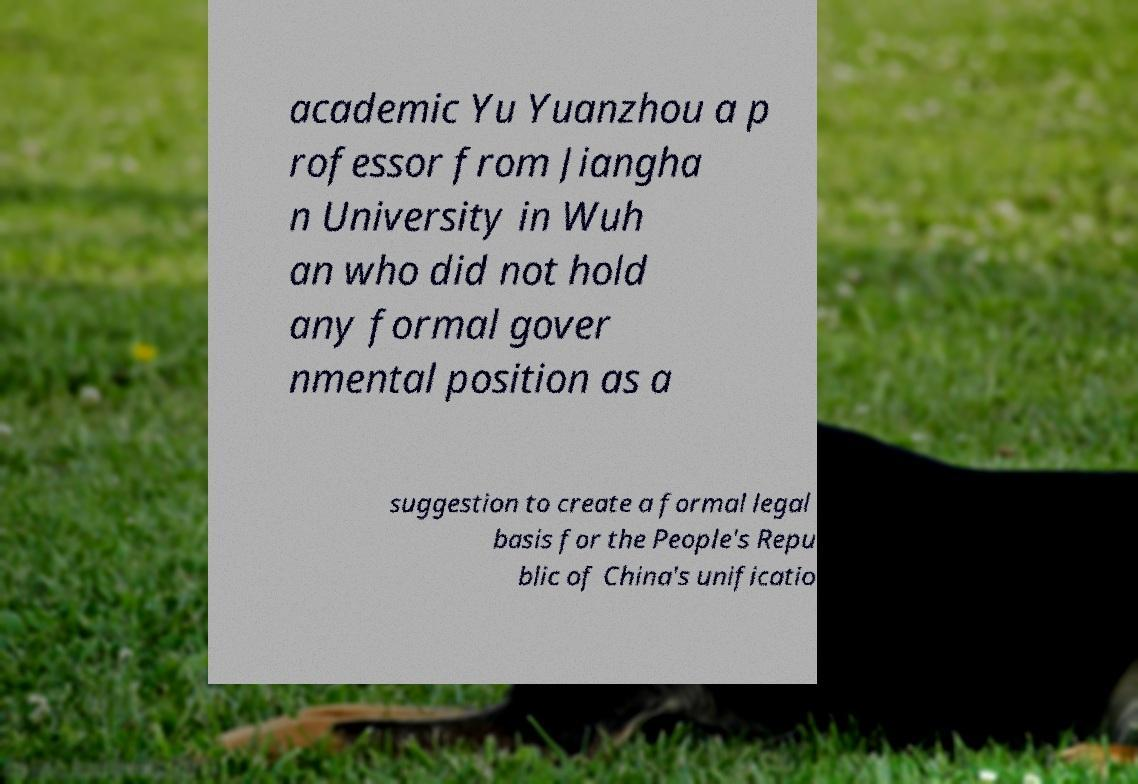What messages or text are displayed in this image? I need them in a readable, typed format. academic Yu Yuanzhou a p rofessor from Jiangha n University in Wuh an who did not hold any formal gover nmental position as a suggestion to create a formal legal basis for the People's Repu blic of China's unificatio 